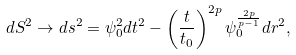<formula> <loc_0><loc_0><loc_500><loc_500>d S ^ { 2 } \rightarrow d s ^ { 2 } = \psi ^ { 2 } _ { 0 } d t ^ { 2 } - \left ( \frac { t } { t _ { 0 } } \right ) ^ { 2 p } \psi ^ { \frac { 2 p } { p - 1 } } _ { 0 } d r ^ { 2 } ,</formula> 